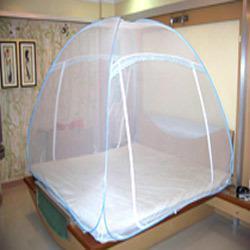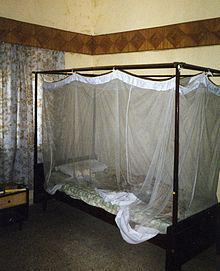The first image is the image on the left, the second image is the image on the right. Assess this claim about the two images: "There is a round tent and a square tent.". Correct or not? Answer yes or no. Yes. 